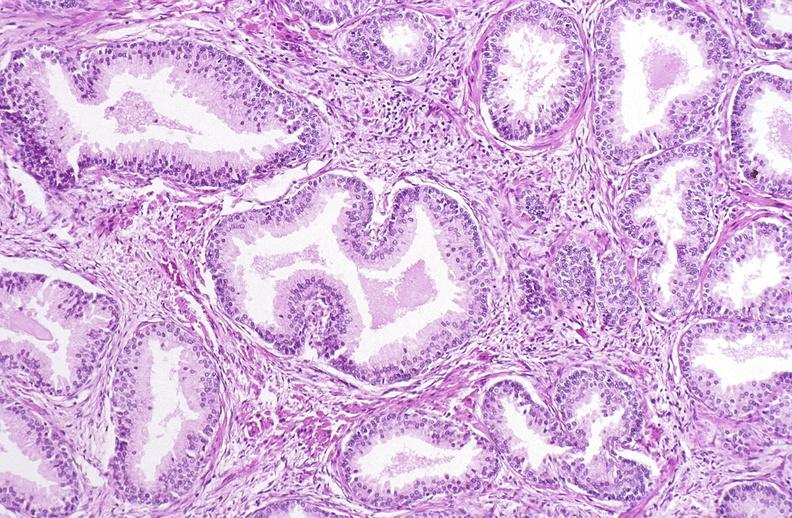does this image show prostate, benign prostatic hyperplasia?
Answer the question using a single word or phrase. Yes 